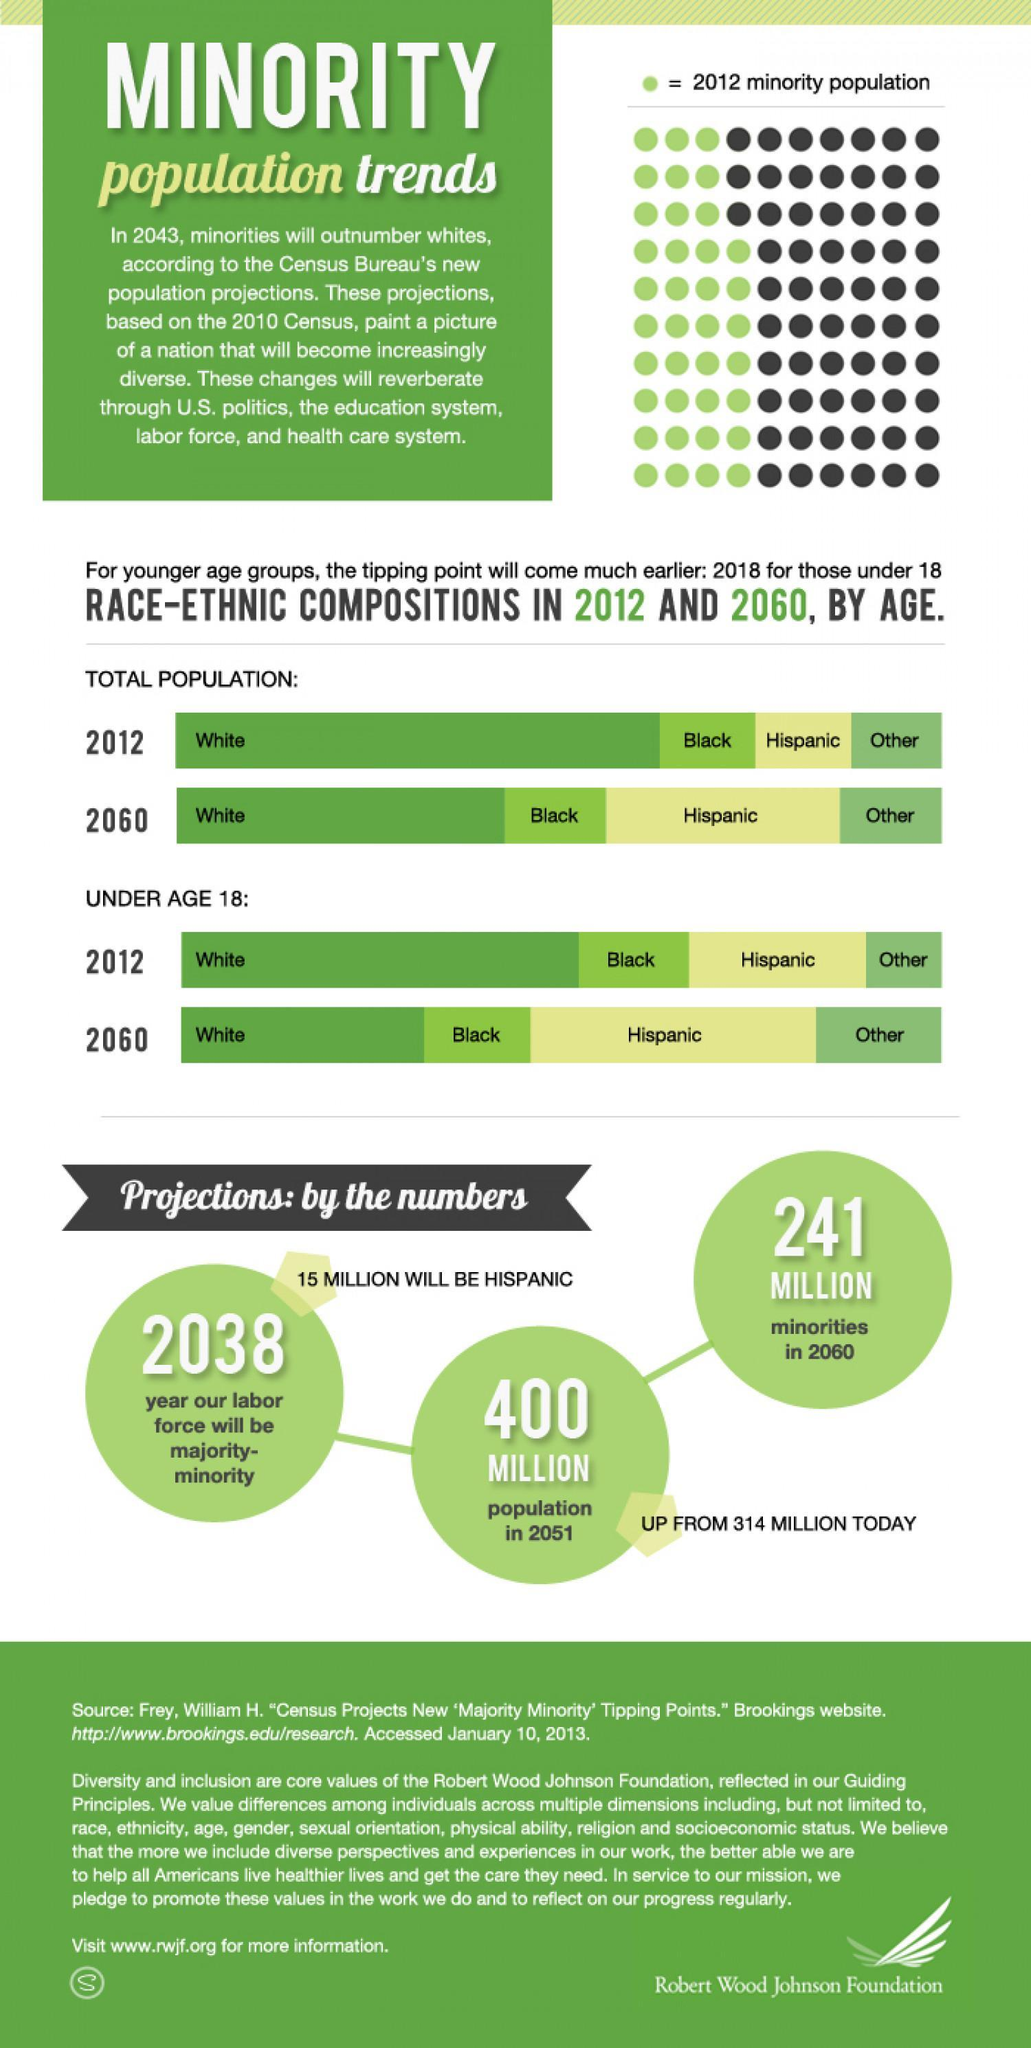Which ethnic race will show a significant decrease in population by 2060?
Answer the question with a short phrase. White By which year will the minority population increase by more than 50% of the majority population, 2038, 2051 or 2060? 2060 Which ethnic race will have the second highest increase in population among below 18 age group by 2060? Other Which ethnic race  will show a significant growth in population by 2060? Hispanic 